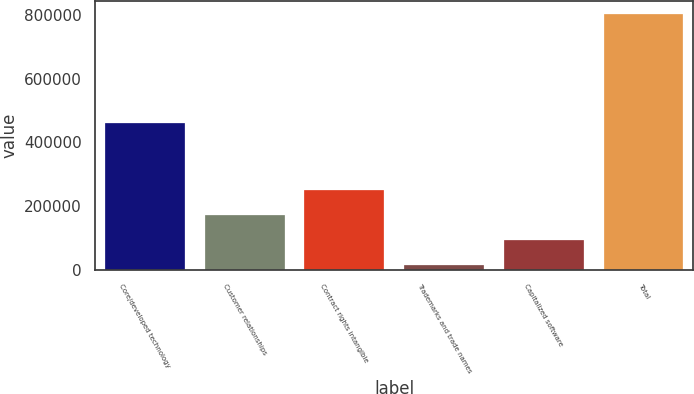Convert chart. <chart><loc_0><loc_0><loc_500><loc_500><bar_chart><fcel>Core/developed technology<fcel>Customer relationships<fcel>Contract rights intangible<fcel>Trademarks and trade names<fcel>Capitalized software<fcel>Total<nl><fcel>460722<fcel>171410<fcel>250205<fcel>13821<fcel>92615.6<fcel>801767<nl></chart> 